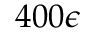Convert formula to latex. <formula><loc_0><loc_0><loc_500><loc_500>4 0 0 \epsilon</formula> 